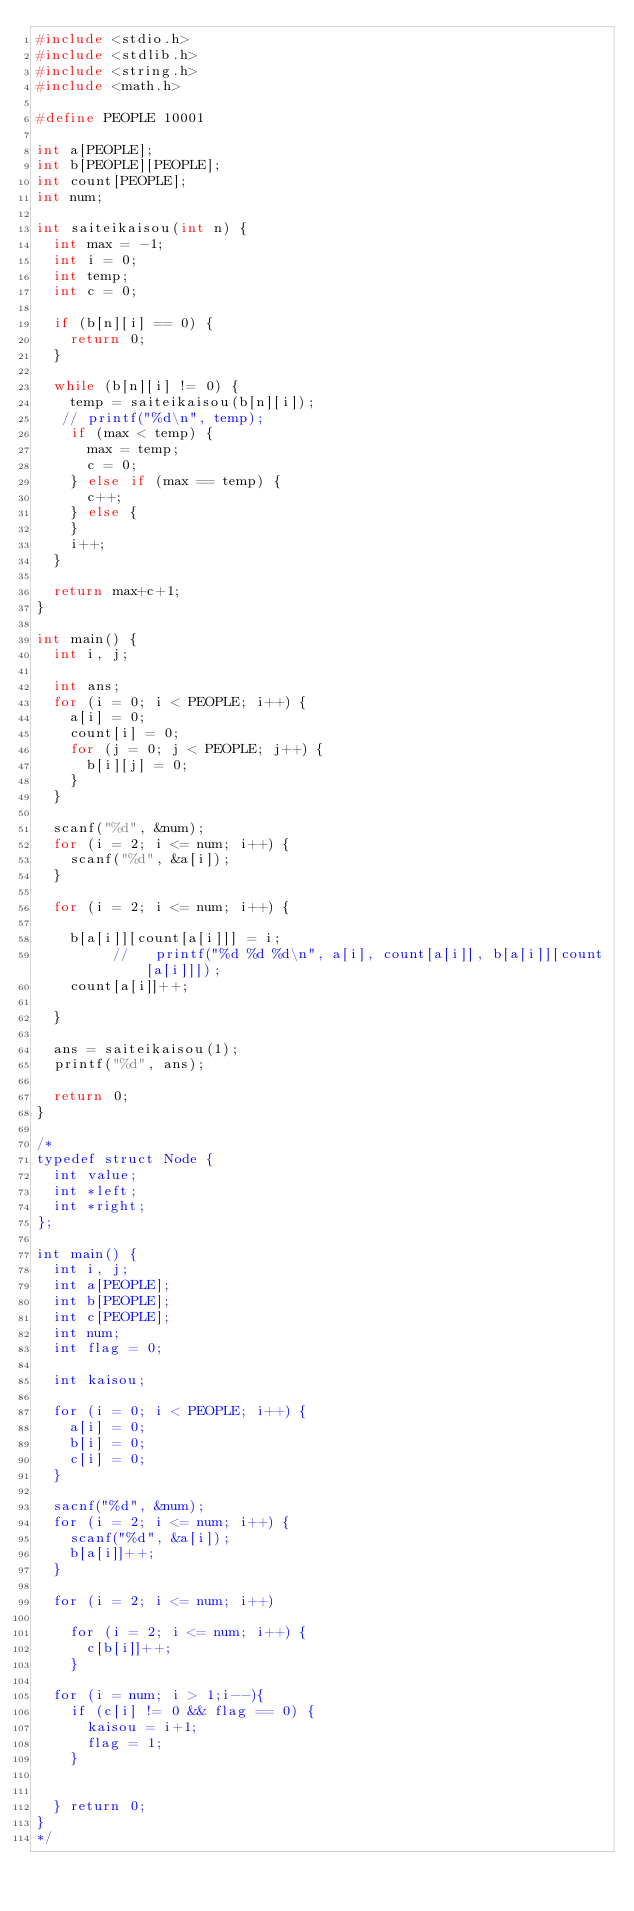Convert code to text. <code><loc_0><loc_0><loc_500><loc_500><_C_>#include <stdio.h>
#include <stdlib.h>
#include <string.h>
#include <math.h>

#define PEOPLE 10001

int a[PEOPLE];
int b[PEOPLE][PEOPLE];
int count[PEOPLE];
int num;

int saiteikaisou(int n) {
  int max = -1;
  int i = 0;
  int temp;
  int c = 0;

  if (b[n][i] == 0) {
    return 0;
  }

  while (b[n][i] != 0) {
    temp = saiteikaisou(b[n][i]);
   // printf("%d\n", temp);
    if (max < temp) {
      max = temp;
      c = 0;
    } else if (max == temp) {
      c++;
    } else {
    }
    i++;
  }

  return max+c+1;
}

int main() {
  int i, j;

  int ans;
  for (i = 0; i < PEOPLE; i++) {
    a[i] = 0;
    count[i] = 0;
    for (j = 0; j < PEOPLE; j++) {
      b[i][j] = 0;
    }
  }

  scanf("%d", &num);
  for (i = 2; i <= num; i++) {
    scanf("%d", &a[i]);
  }

  for (i = 2; i <= num; i++) {

    b[a[i]][count[a[i]]] = i;
         //   printf("%d %d %d\n", a[i], count[a[i]], b[a[i]][count[a[i]]]);
    count[a[i]]++;

  }

  ans = saiteikaisou(1);
  printf("%d", ans);

  return 0;
}

/*
typedef struct Node {
  int value;
  int *left;
  int *right;
};

int main() {
  int i, j;
  int a[PEOPLE];
  int b[PEOPLE];
  int c[PEOPLE];
  int num;
  int flag = 0;

  int kaisou;

  for (i = 0; i < PEOPLE; i++) {
    a[i] = 0;
    b[i] = 0;
    c[i] = 0;
  }

  sacnf("%d", &num);
  for (i = 2; i <= num; i++) {
    scanf("%d", &a[i]);
    b[a[i]]++;
  }

  for (i = 2; i <= num; i++)

    for (i = 2; i <= num; i++) {
      c[b[i]]++;
    }

  for (i = num; i > 1;i--){
    if (c[i] != 0 && flag == 0) {
      kaisou = i+1;
      flag = 1;
    }


  } return 0;
}
*/</code> 